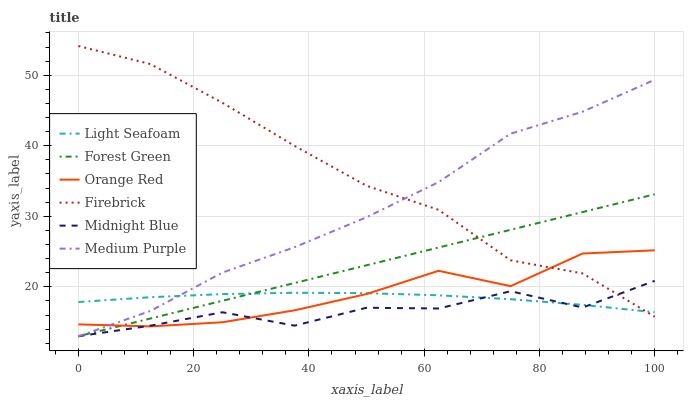Does Midnight Blue have the minimum area under the curve?
Answer yes or no. Yes. Does Firebrick have the maximum area under the curve?
Answer yes or no. Yes. Does Medium Purple have the minimum area under the curve?
Answer yes or no. No. Does Medium Purple have the maximum area under the curve?
Answer yes or no. No. Is Forest Green the smoothest?
Answer yes or no. Yes. Is Midnight Blue the roughest?
Answer yes or no. Yes. Is Firebrick the smoothest?
Answer yes or no. No. Is Firebrick the roughest?
Answer yes or no. No. Does Midnight Blue have the lowest value?
Answer yes or no. Yes. Does Firebrick have the lowest value?
Answer yes or no. No. Does Firebrick have the highest value?
Answer yes or no. Yes. Does Medium Purple have the highest value?
Answer yes or no. No. Does Orange Red intersect Forest Green?
Answer yes or no. Yes. Is Orange Red less than Forest Green?
Answer yes or no. No. Is Orange Red greater than Forest Green?
Answer yes or no. No. 